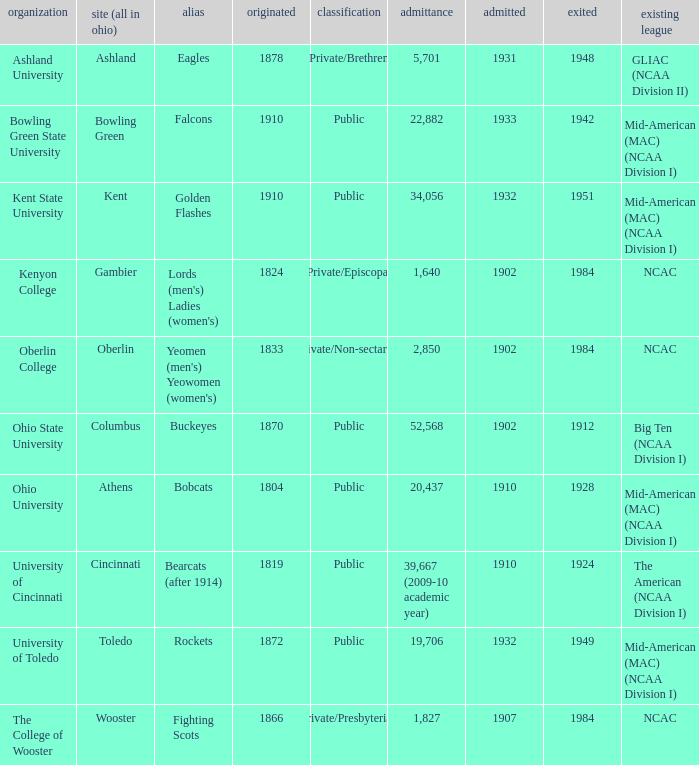What is the enrollment for Ashland University? 5701.0. 